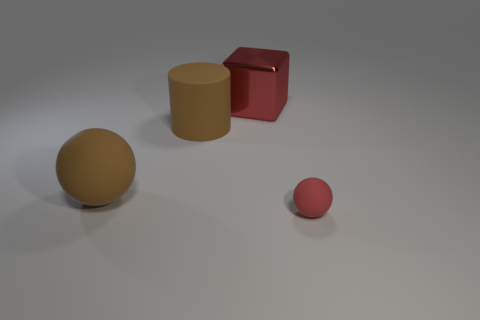Add 1 tiny rubber blocks. How many objects exist? 5 Subtract all cylinders. How many objects are left? 3 Subtract 0 blue cylinders. How many objects are left? 4 Subtract all big brown cylinders. Subtract all small blue objects. How many objects are left? 3 Add 2 matte cylinders. How many matte cylinders are left? 3 Add 3 matte balls. How many matte balls exist? 5 